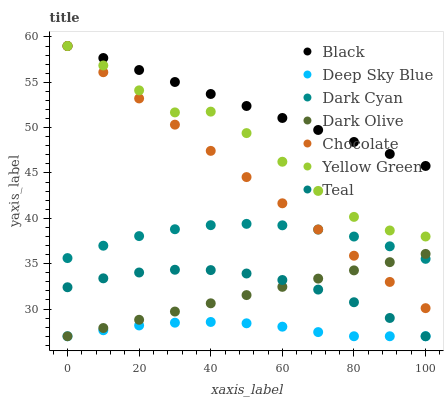Does Deep Sky Blue have the minimum area under the curve?
Answer yes or no. Yes. Does Black have the maximum area under the curve?
Answer yes or no. Yes. Does Yellow Green have the minimum area under the curve?
Answer yes or no. No. Does Yellow Green have the maximum area under the curve?
Answer yes or no. No. Is Black the smoothest?
Answer yes or no. Yes. Is Yellow Green the roughest?
Answer yes or no. Yes. Is Dark Olive the smoothest?
Answer yes or no. No. Is Dark Olive the roughest?
Answer yes or no. No. Does Teal have the lowest value?
Answer yes or no. Yes. Does Yellow Green have the lowest value?
Answer yes or no. No. Does Black have the highest value?
Answer yes or no. Yes. Does Dark Olive have the highest value?
Answer yes or no. No. Is Dark Olive less than Black?
Answer yes or no. Yes. Is Dark Cyan greater than Deep Sky Blue?
Answer yes or no. Yes. Does Teal intersect Dark Olive?
Answer yes or no. Yes. Is Teal less than Dark Olive?
Answer yes or no. No. Is Teal greater than Dark Olive?
Answer yes or no. No. Does Dark Olive intersect Black?
Answer yes or no. No. 